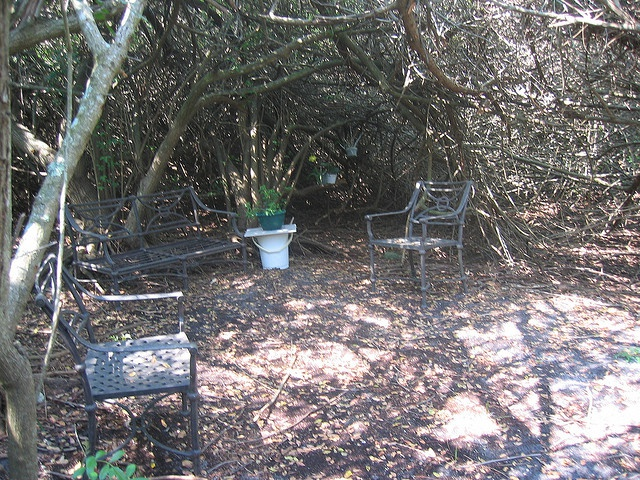Describe the objects in this image and their specific colors. I can see chair in gray, lightgray, and darkgray tones, bench in gray, black, and darkblue tones, chair in gray, black, and darkgray tones, potted plant in gray, teal, darkgreen, and black tones, and potted plant in gray, black, purple, darkgreen, and teal tones in this image. 